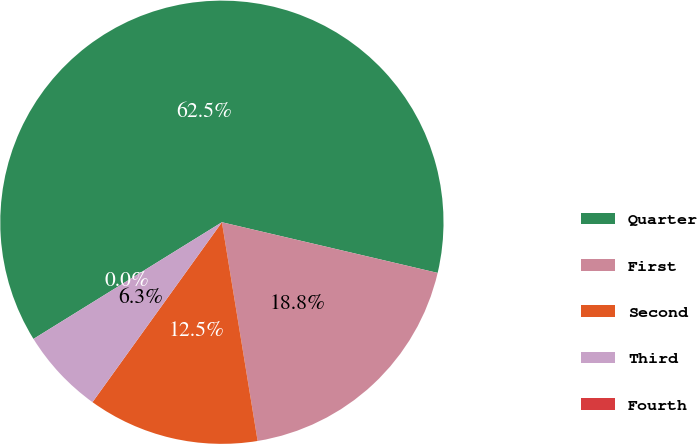<chart> <loc_0><loc_0><loc_500><loc_500><pie_chart><fcel>Quarter<fcel>First<fcel>Second<fcel>Third<fcel>Fourth<nl><fcel>62.49%<fcel>18.75%<fcel>12.5%<fcel>6.25%<fcel>0.0%<nl></chart> 